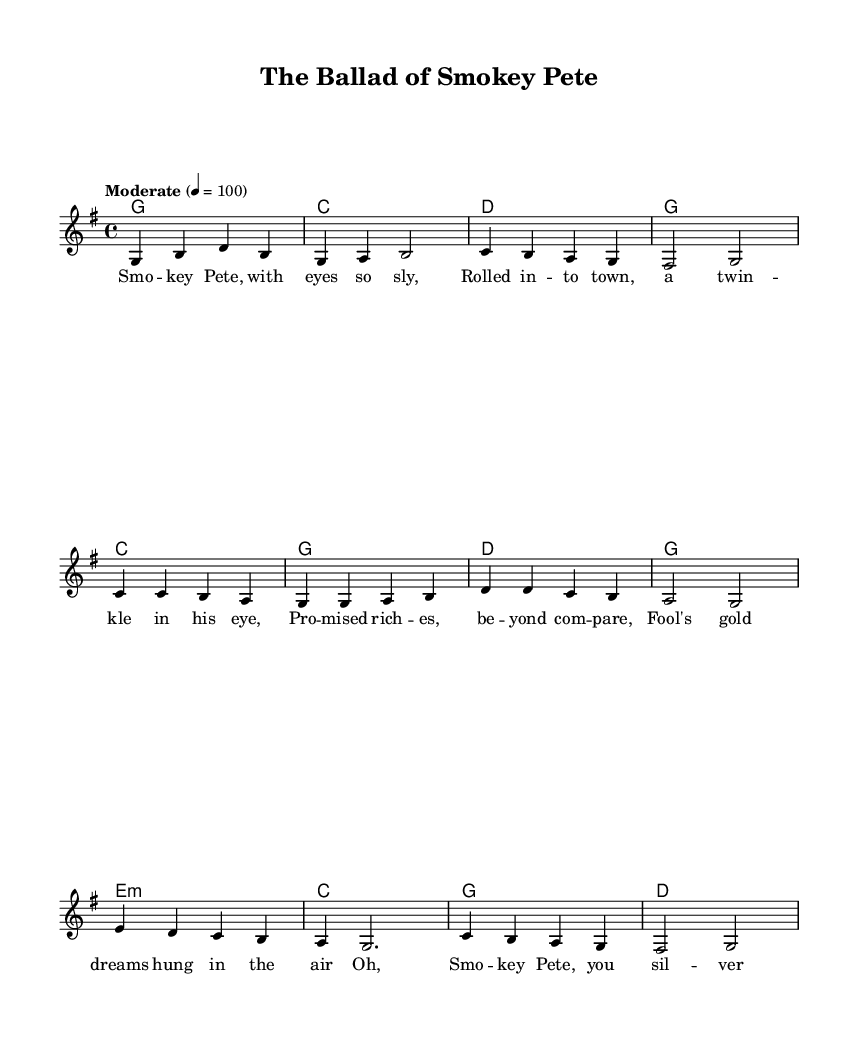What is the key signature of this music? The key signature is G major, indicated by one sharp (F#), which means the piece predominantly uses G major scale notes.
Answer: G major What is the time signature of this piece? The time signature is 4/4, which allows for four beats in each measure and is common in many genres, including Country Rock.
Answer: 4/4 What is the tempo marking of the piece? The tempo marking is "Moderate" at 100 beats per minute, which indicates a moderately paced performance of the song.
Answer: Moderate How many measures are in the verse? The verse consists of four measures, as counted in the melody section; each of the four lines corresponds to a single measure.
Answer: Four What type of chord is used in the bridge? The chord used in the bridge is E minor (e:m), as indicated by the notation for the E chord with a minor quality in the harmonies.
Answer: E minor What is the lyrical subject of the song? The lyrical subject revolves around a character named Smokey Pete, who is portrayed as a con artist with cunning and charm, focusing on his schemes.
Answer: Con artist How does the chorus describe Smokey Pete? The chorus describes Smokey Pete as a "silver-tongued devil," indicating his persuasive and charming nature, which is a common trait of con artists.
Answer: Silver-tongued devil 